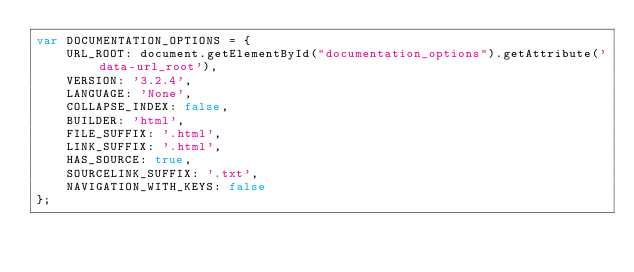<code> <loc_0><loc_0><loc_500><loc_500><_JavaScript_>var DOCUMENTATION_OPTIONS = {
    URL_ROOT: document.getElementById("documentation_options").getAttribute('data-url_root'),
    VERSION: '3.2.4',
    LANGUAGE: 'None',
    COLLAPSE_INDEX: false,
    BUILDER: 'html',
    FILE_SUFFIX: '.html',
    LINK_SUFFIX: '.html',
    HAS_SOURCE: true,
    SOURCELINK_SUFFIX: '.txt',
    NAVIGATION_WITH_KEYS: false
};</code> 